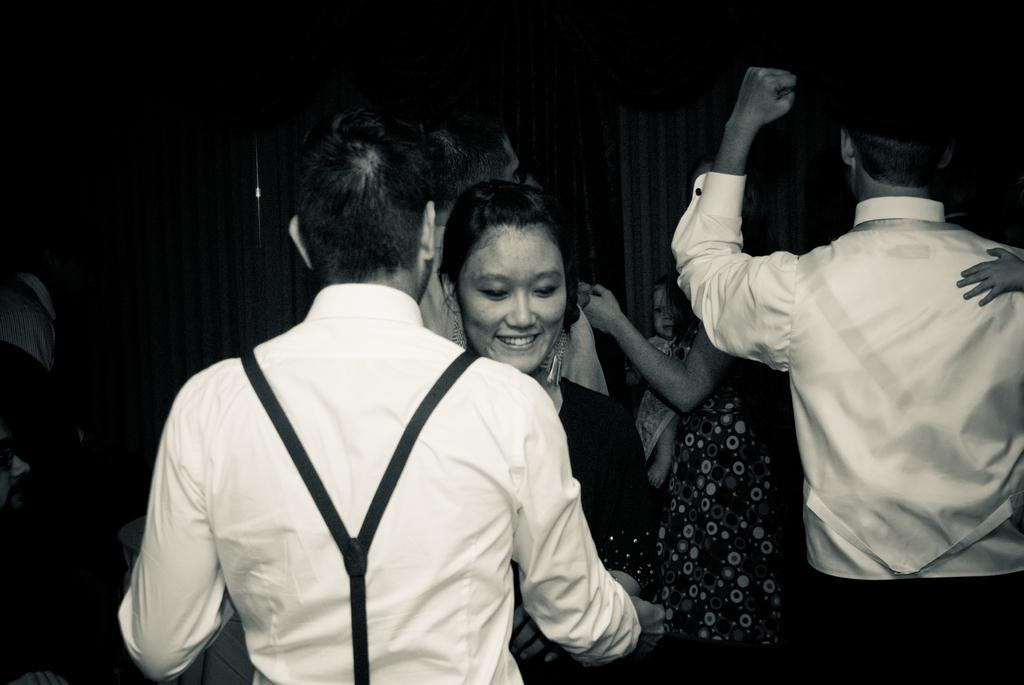What is happening in the image involving a group of people? There is a group of people standing in the image. Can you describe the facial expression of one of the individuals in the image? A woman is smiling in the image. What is happening in the background of the image? There is a person carrying a baby in the background of the image. What type of window treatment is present in the image? Curtains are present in the image. What type of tree can be seen in the image? There is no tree present in the image. What color is the orange that the person is holding in the image? There is no orange present in the image. 